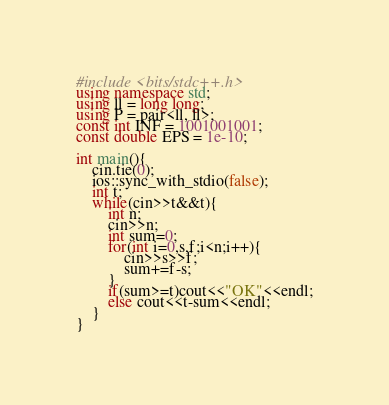Convert code to text. <code><loc_0><loc_0><loc_500><loc_500><_C++_>#include <bits/stdc++.h>
using namespace std;
using ll = long long;
using P = pair<ll, ll>;
const int INF = 1001001001;
const double EPS = 1e-10;

int main(){
    cin.tie(0);
    ios::sync_with_stdio(false);
    int t;
    while(cin>>t&&t){
        int n;
        cin>>n;
        int sum=0;
        for(int i=0,s,f;i<n;i++){
            cin>>s>>f;
            sum+=f-s;
        }
        if(sum>=t)cout<<"OK"<<endl;
        else cout<<t-sum<<endl;
    }
}
</code> 